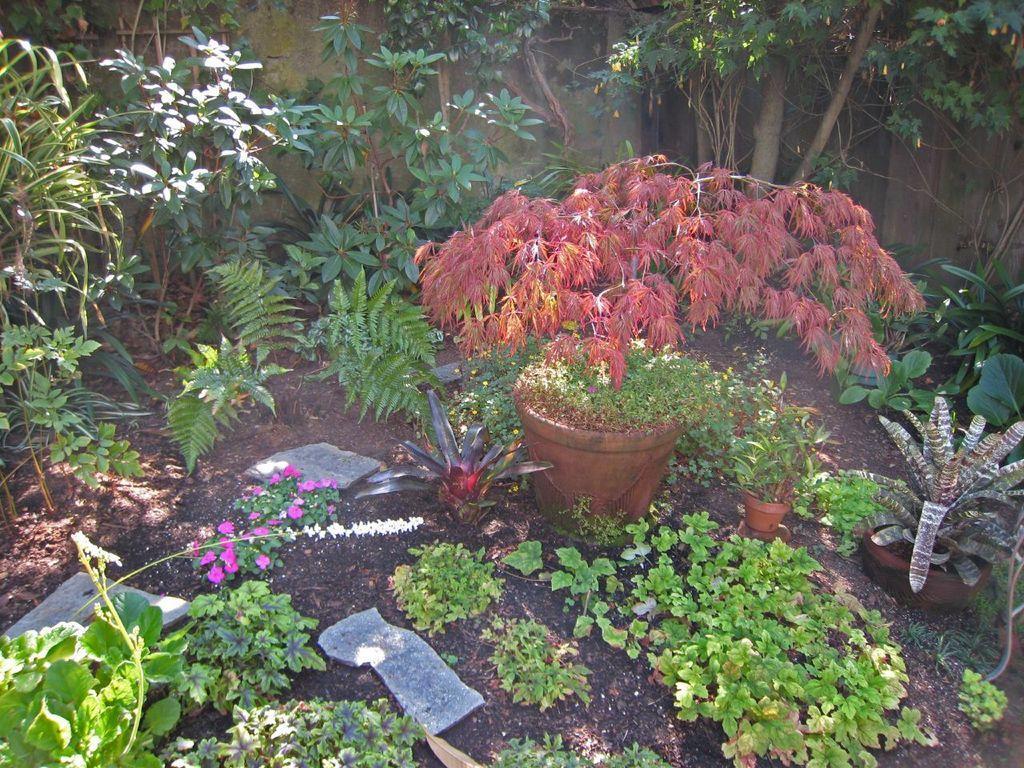Describe this image in one or two sentences. In this picture we can see plants, pots and flowers. In the background of the image we can see wall. 